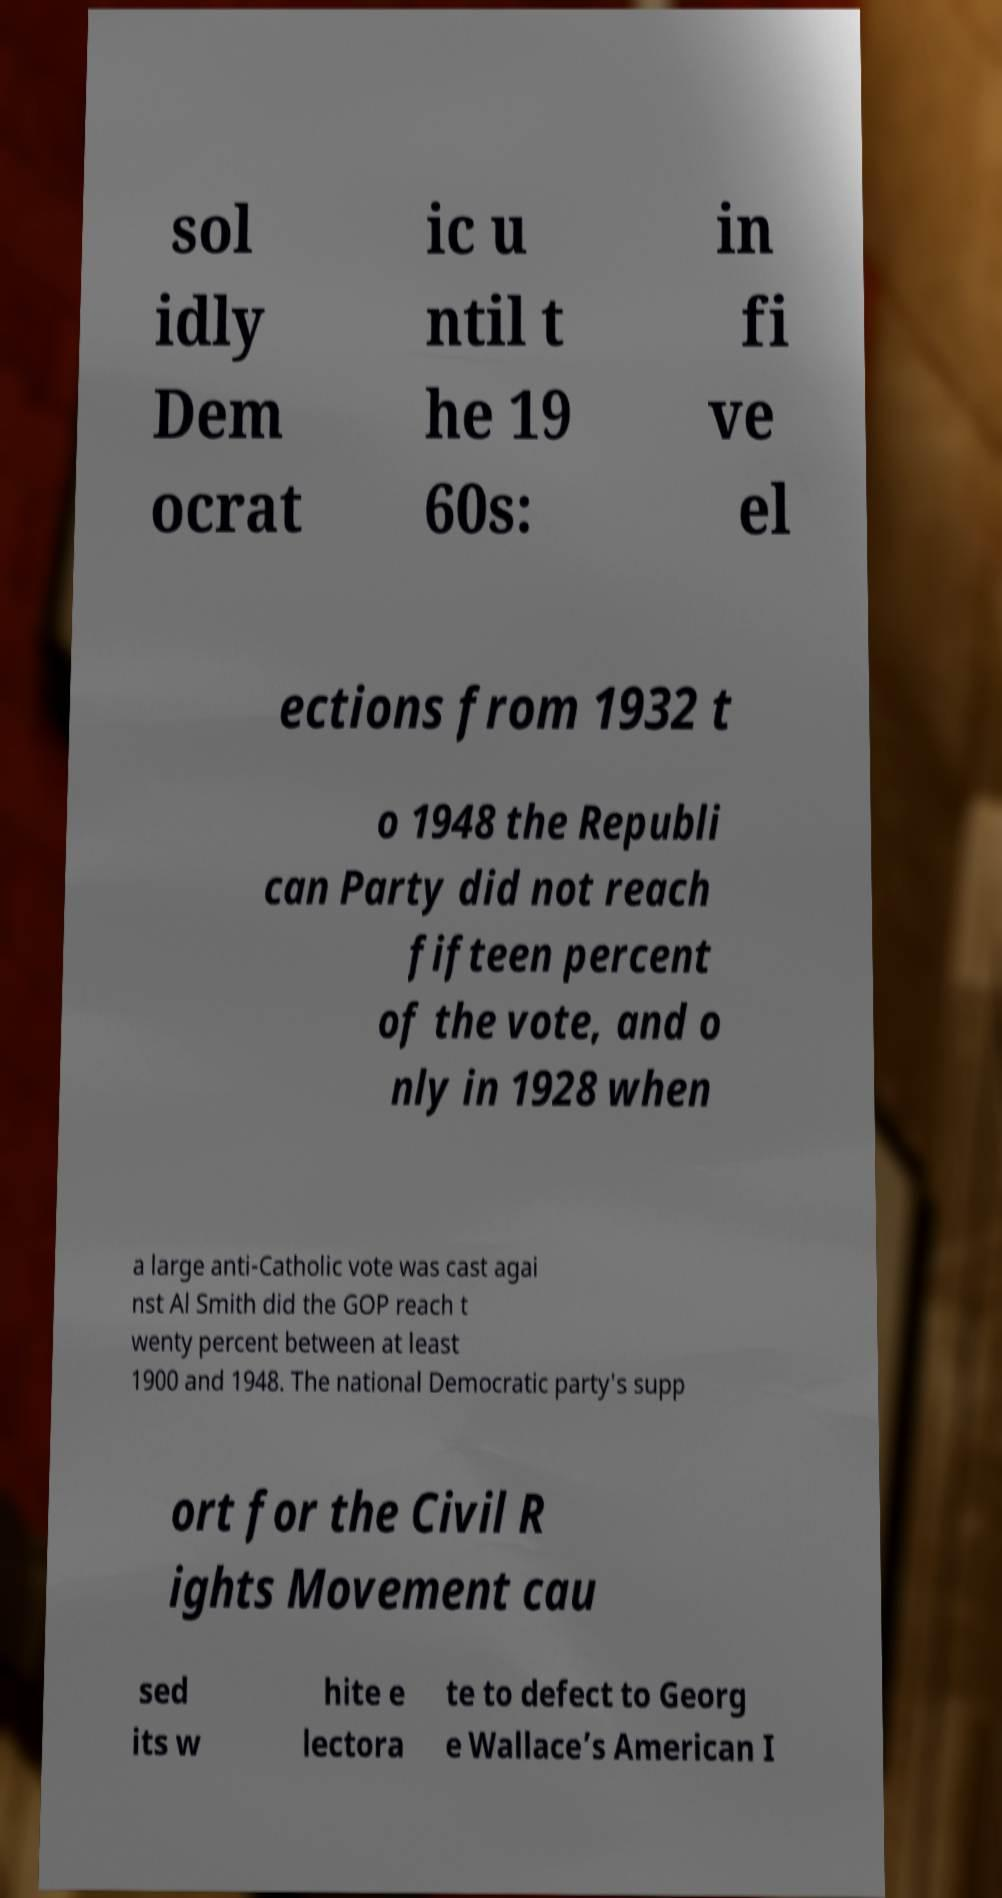Please identify and transcribe the text found in this image. sol idly Dem ocrat ic u ntil t he 19 60s: in fi ve el ections from 1932 t o 1948 the Republi can Party did not reach fifteen percent of the vote, and o nly in 1928 when a large anti-Catholic vote was cast agai nst Al Smith did the GOP reach t wenty percent between at least 1900 and 1948. The national Democratic party's supp ort for the Civil R ights Movement cau sed its w hite e lectora te to defect to Georg e Wallace’s American I 